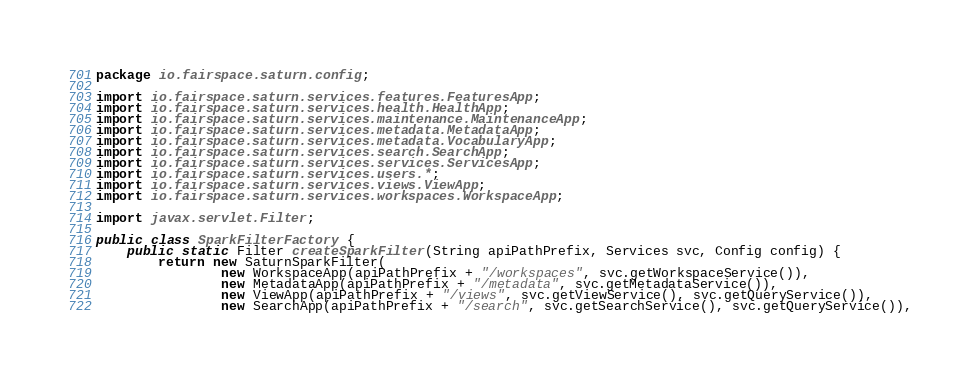Convert code to text. <code><loc_0><loc_0><loc_500><loc_500><_Java_>package io.fairspace.saturn.config;

import io.fairspace.saturn.services.features.FeaturesApp;
import io.fairspace.saturn.services.health.HealthApp;
import io.fairspace.saturn.services.maintenance.MaintenanceApp;
import io.fairspace.saturn.services.metadata.MetadataApp;
import io.fairspace.saturn.services.metadata.VocabularyApp;
import io.fairspace.saturn.services.search.SearchApp;
import io.fairspace.saturn.services.services.ServicesApp;
import io.fairspace.saturn.services.users.*;
import io.fairspace.saturn.services.views.ViewApp;
import io.fairspace.saturn.services.workspaces.WorkspaceApp;

import javax.servlet.Filter;

public class SparkFilterFactory {
    public static Filter createSparkFilter(String apiPathPrefix, Services svc, Config config) {
        return new SaturnSparkFilter(
                new WorkspaceApp(apiPathPrefix + "/workspaces", svc.getWorkspaceService()),
                new MetadataApp(apiPathPrefix + "/metadata", svc.getMetadataService()),
                new ViewApp(apiPathPrefix + "/views", svc.getViewService(), svc.getQueryService()),
                new SearchApp(apiPathPrefix + "/search", svc.getSearchService(), svc.getQueryService()),</code> 